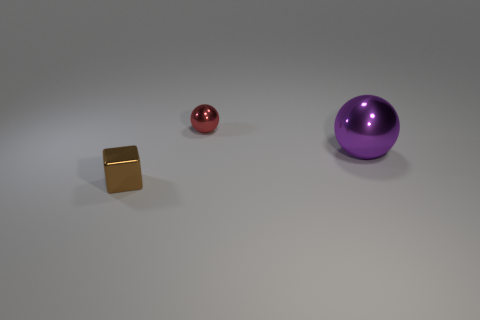Subtract all purple spheres. How many spheres are left? 1 Subtract 1 blocks. How many blocks are left? 0 Add 3 large gray blocks. How many objects exist? 6 Subtract all spheres. How many objects are left? 1 Add 3 tiny brown metal cubes. How many tiny brown metal cubes are left? 4 Add 1 big purple balls. How many big purple balls exist? 2 Subtract 0 cyan cubes. How many objects are left? 3 Subtract all green spheres. Subtract all cyan cubes. How many spheres are left? 2 Subtract all purple balls. How many yellow blocks are left? 0 Subtract all big things. Subtract all large metal spheres. How many objects are left? 1 